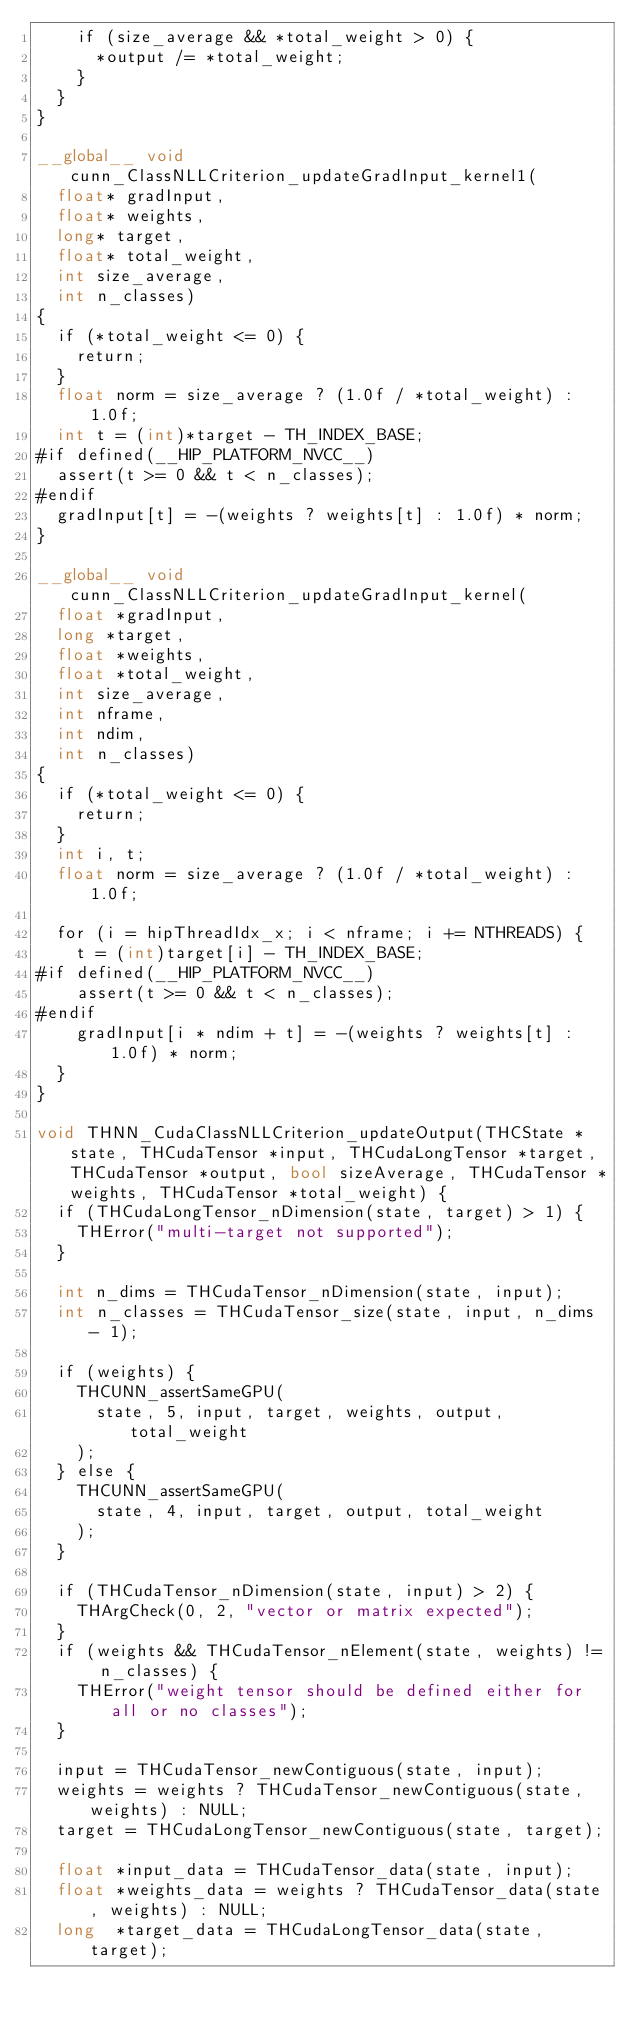Convert code to text. <code><loc_0><loc_0><loc_500><loc_500><_Cuda_>    if (size_average && *total_weight > 0) {
      *output /= *total_weight;
    }
  }
}

__global__ void cunn_ClassNLLCriterion_updateGradInput_kernel1( 
  float* gradInput,
  float* weights,
  long* target,
  float* total_weight,
  int size_average,
  int n_classes)
{
  if (*total_weight <= 0) {
    return;
  }
  float norm = size_average ? (1.0f / *total_weight) : 1.0f;
  int t = (int)*target - TH_INDEX_BASE;
#if defined(__HIP_PLATFORM_NVCC__)
  assert(t >= 0 && t < n_classes);
#endif
  gradInput[t] = -(weights ? weights[t] : 1.0f) * norm;
}

__global__ void cunn_ClassNLLCriterion_updateGradInput_kernel( 
  float *gradInput,
  long *target,
  float *weights,
  float *total_weight,
  int size_average,
  int nframe,
  int ndim,
  int n_classes)
{
  if (*total_weight <= 0) {
    return;
  }
  int i, t;
  float norm = size_average ? (1.0f / *total_weight) : 1.0f;

  for (i = hipThreadIdx_x; i < nframe; i += NTHREADS) {
    t = (int)target[i] - TH_INDEX_BASE;
#if defined(__HIP_PLATFORM_NVCC__)
    assert(t >= 0 && t < n_classes);
#endif
    gradInput[i * ndim + t] = -(weights ? weights[t] : 1.0f) * norm;
  }
}

void THNN_CudaClassNLLCriterion_updateOutput(THCState *state, THCudaTensor *input, THCudaLongTensor *target, THCudaTensor *output, bool sizeAverage, THCudaTensor *weights, THCudaTensor *total_weight) {
  if (THCudaLongTensor_nDimension(state, target) > 1) {
    THError("multi-target not supported");
  }

  int n_dims = THCudaTensor_nDimension(state, input);
  int n_classes = THCudaTensor_size(state, input, n_dims - 1);

  if (weights) {
    THCUNN_assertSameGPU(
      state, 5, input, target, weights, output, total_weight
    );
  } else {
    THCUNN_assertSameGPU(
      state, 4, input, target, output, total_weight
    );
  }

  if (THCudaTensor_nDimension(state, input) > 2) {
    THArgCheck(0, 2, "vector or matrix expected");
  }
  if (weights && THCudaTensor_nElement(state, weights) != n_classes) {
    THError("weight tensor should be defined either for all or no classes");
  }

  input = THCudaTensor_newContiguous(state, input);
  weights = weights ? THCudaTensor_newContiguous(state, weights) : NULL;
  target = THCudaLongTensor_newContiguous(state, target);

  float *input_data = THCudaTensor_data(state, input);
  float *weights_data = weights ? THCudaTensor_data(state, weights) : NULL;
  long  *target_data = THCudaLongTensor_data(state, target);</code> 